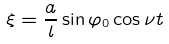<formula> <loc_0><loc_0><loc_500><loc_500>\xi = \frac { a } { l } \sin \varphi _ { 0 } \cos \nu t</formula> 